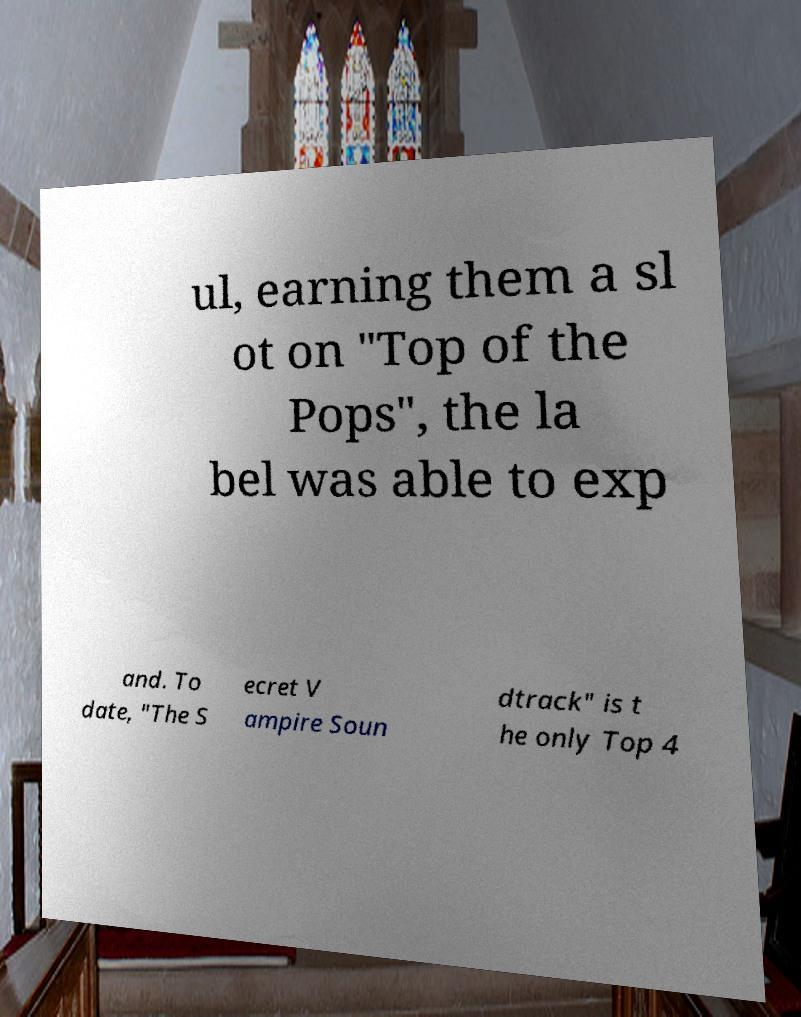Can you read and provide the text displayed in the image?This photo seems to have some interesting text. Can you extract and type it out for me? ul, earning them a sl ot on "Top of the Pops", the la bel was able to exp and. To date, "The S ecret V ampire Soun dtrack" is t he only Top 4 